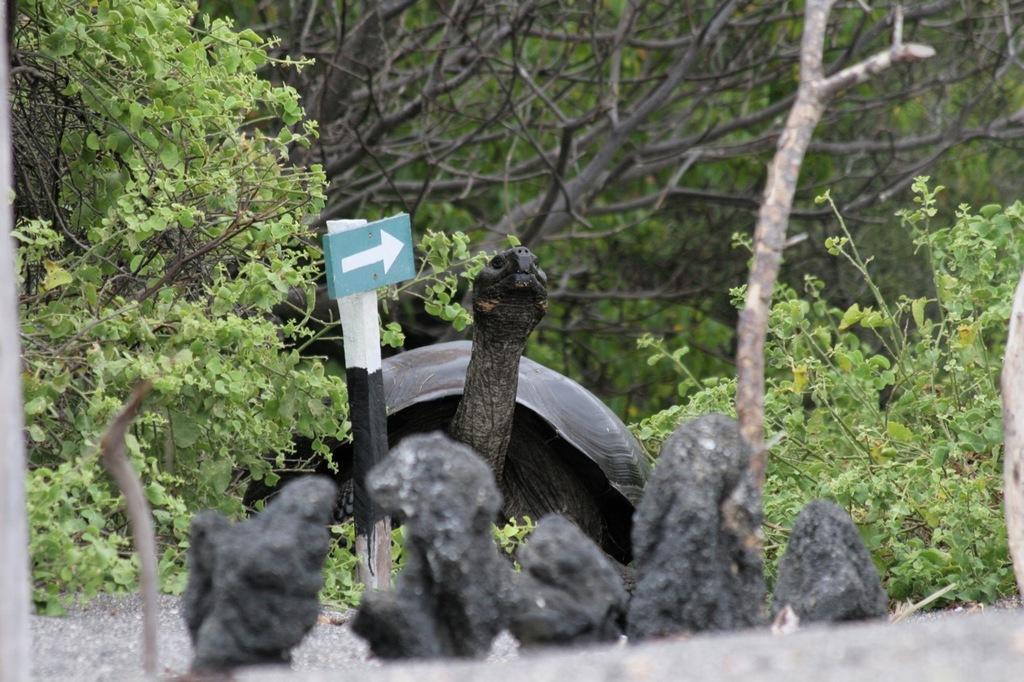Could you give a brief overview of what you see in this image? This image is taken outdoors. At the bottom of the image there is a road. In the background there are many trees and plants with stems, branches and green leaves. In the middle of the image there is a big tortoise on the ground and there is a signboard. There are a few stones on the ground. 